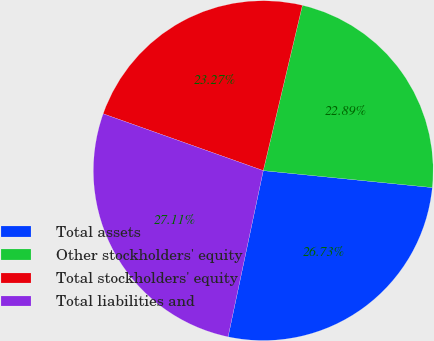<chart> <loc_0><loc_0><loc_500><loc_500><pie_chart><fcel>Total assets<fcel>Other stockholders' equity<fcel>Total stockholders' equity<fcel>Total liabilities and<nl><fcel>26.73%<fcel>22.89%<fcel>23.27%<fcel>27.11%<nl></chart> 